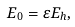Convert formula to latex. <formula><loc_0><loc_0><loc_500><loc_500>E _ { 0 } = \varepsilon E _ { h } ,</formula> 